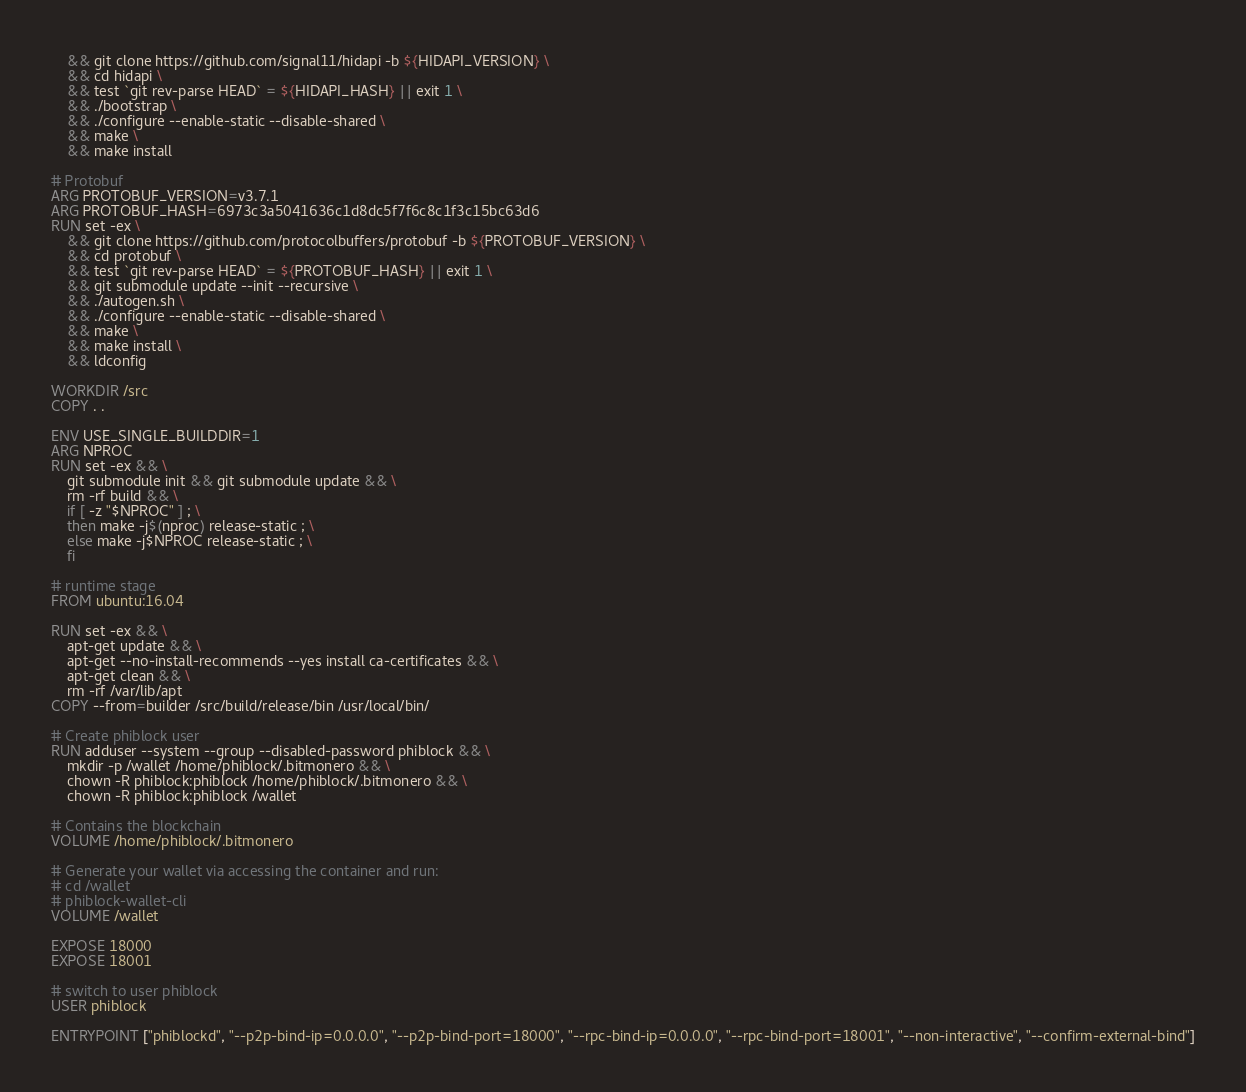<code> <loc_0><loc_0><loc_500><loc_500><_Dockerfile_>    && git clone https://github.com/signal11/hidapi -b ${HIDAPI_VERSION} \
    && cd hidapi \
    && test `git rev-parse HEAD` = ${HIDAPI_HASH} || exit 1 \
    && ./bootstrap \
    && ./configure --enable-static --disable-shared \
    && make \
    && make install

# Protobuf
ARG PROTOBUF_VERSION=v3.7.1
ARG PROTOBUF_HASH=6973c3a5041636c1d8dc5f7f6c8c1f3c15bc63d6
RUN set -ex \
    && git clone https://github.com/protocolbuffers/protobuf -b ${PROTOBUF_VERSION} \
    && cd protobuf \
    && test `git rev-parse HEAD` = ${PROTOBUF_HASH} || exit 1 \
    && git submodule update --init --recursive \
    && ./autogen.sh \
    && ./configure --enable-static --disable-shared \
    && make \
    && make install \
    && ldconfig

WORKDIR /src
COPY . .

ENV USE_SINGLE_BUILDDIR=1
ARG NPROC
RUN set -ex && \
    git submodule init && git submodule update && \
    rm -rf build && \
    if [ -z "$NPROC" ] ; \
    then make -j$(nproc) release-static ; \
    else make -j$NPROC release-static ; \
    fi

# runtime stage
FROM ubuntu:16.04

RUN set -ex && \
    apt-get update && \
    apt-get --no-install-recommends --yes install ca-certificates && \
    apt-get clean && \
    rm -rf /var/lib/apt
COPY --from=builder /src/build/release/bin /usr/local/bin/

# Create phiblock user
RUN adduser --system --group --disabled-password phiblock && \
	mkdir -p /wallet /home/phiblock/.bitmonero && \
	chown -R phiblock:phiblock /home/phiblock/.bitmonero && \
	chown -R phiblock:phiblock /wallet

# Contains the blockchain
VOLUME /home/phiblock/.bitmonero

# Generate your wallet via accessing the container and run:
# cd /wallet
# phiblock-wallet-cli
VOLUME /wallet

EXPOSE 18000
EXPOSE 18001

# switch to user phiblock
USER phiblock

ENTRYPOINT ["phiblockd", "--p2p-bind-ip=0.0.0.0", "--p2p-bind-port=18000", "--rpc-bind-ip=0.0.0.0", "--rpc-bind-port=18001", "--non-interactive", "--confirm-external-bind"]

</code> 